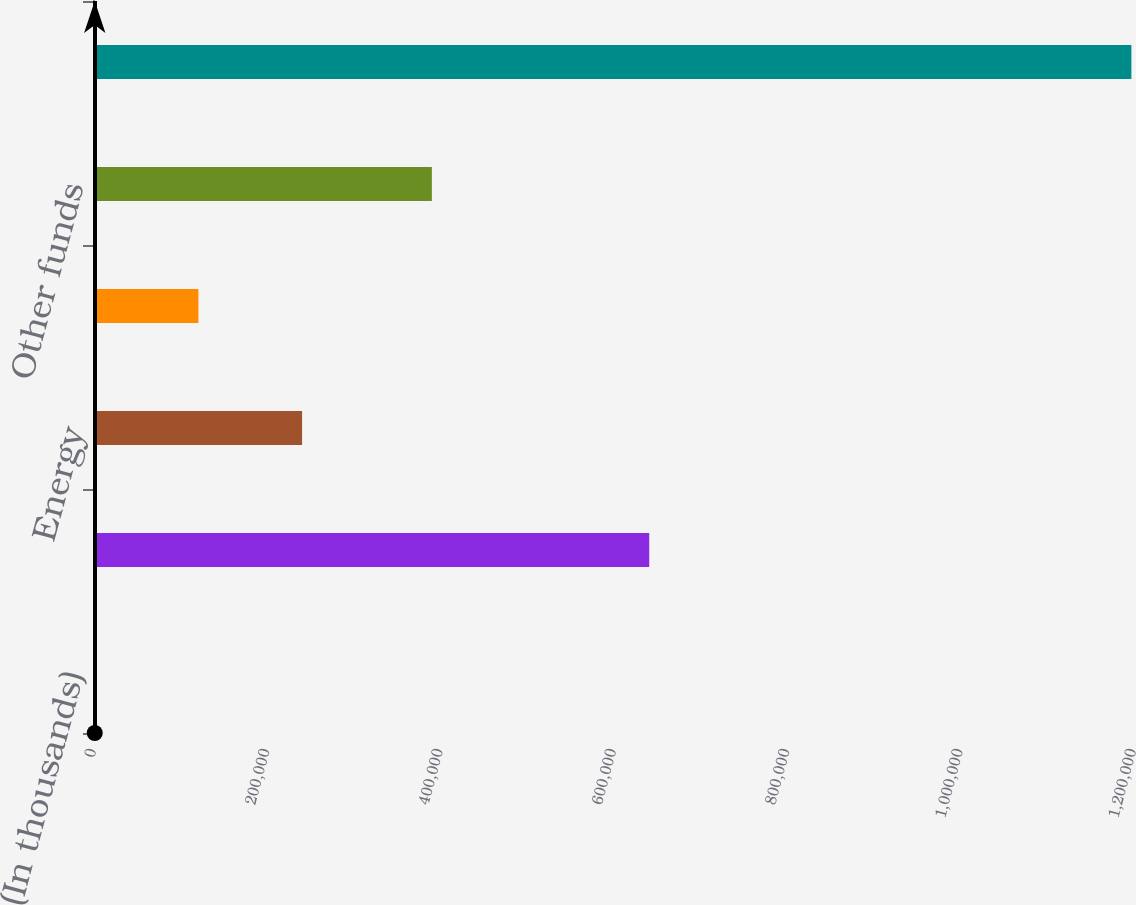Convert chart to OTSL. <chart><loc_0><loc_0><loc_500><loc_500><bar_chart><fcel>(In thousands)<fcel>Real estate<fcel>Energy<fcel>Hedged equity<fcel>Other funds<fcel>Total<nl><fcel>2016<fcel>641783<fcel>241242<fcel>121629<fcel>391002<fcel>1.19815e+06<nl></chart> 